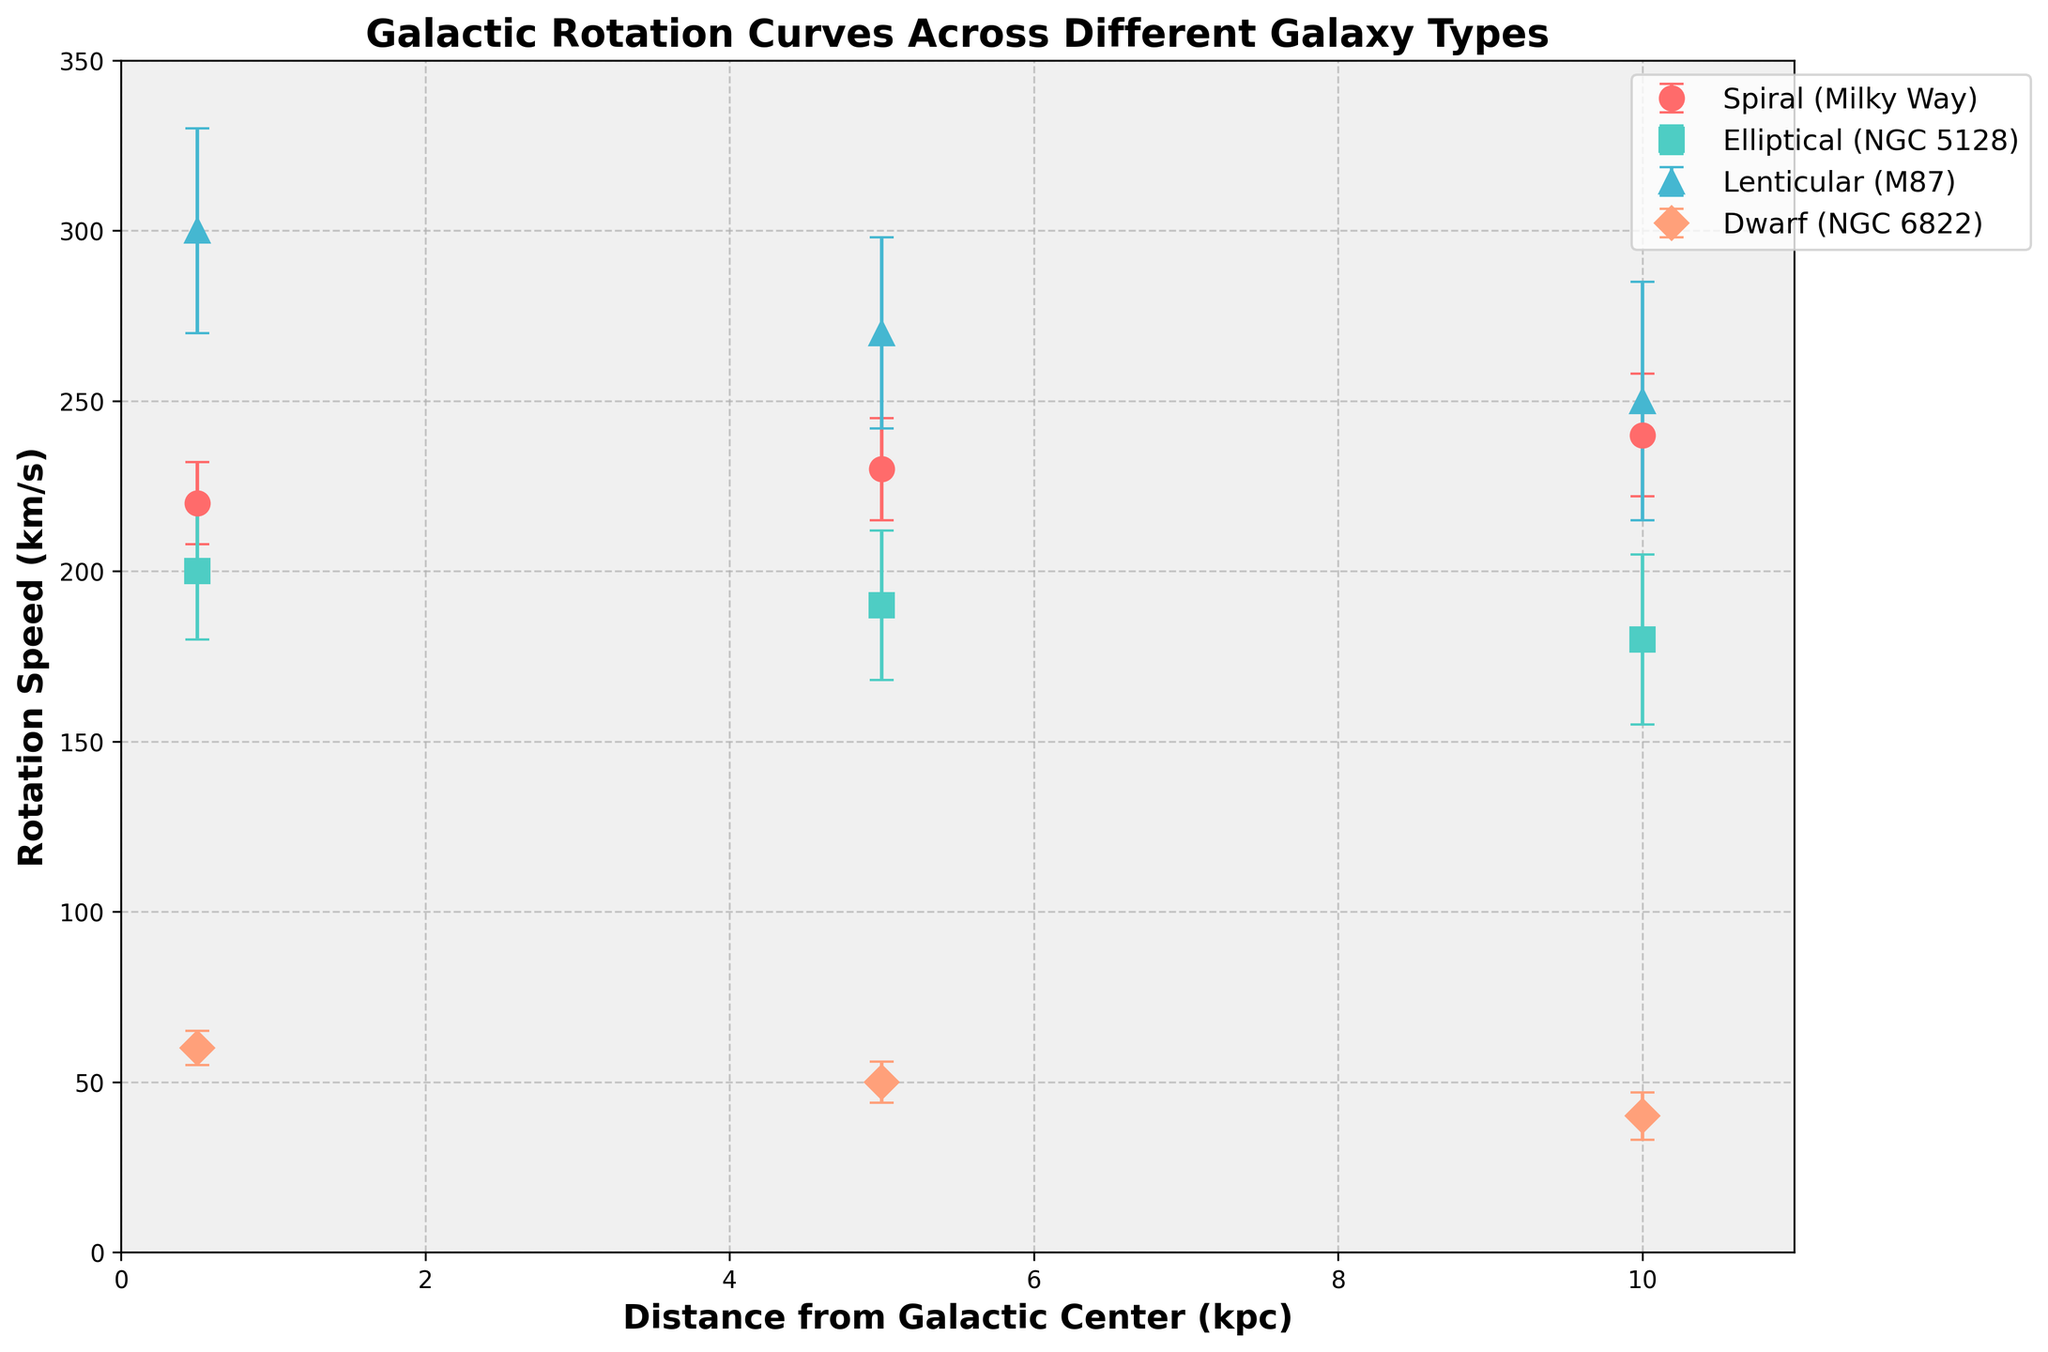What's the title of the plot? The title is usually found at the top of the plot. By looking at the figure, one can easily read the title provided there.
Answer: Galactic Rotation Curves Across Different Galaxy Types Which galaxy type has the highest rotation speed at 0.5 kpc? Check the data points at 0.5 kpc for each galaxy type and compare their rotation speeds. The lenticular galaxy (M87) has the highest point.
Answer: Lenticular What are the x-axis and y-axis labels? The x-axis label is found along the horizontal axis and the y-axis label is found along the vertical axis. By reading both labels, one can identify them.
Answer: Distance from Galactic Center (kpc) and Rotation Speed (km/s) How does the rotation speed of the Milky Way change from 0.5 kpc to 10 kpc? Compare the rotation speed values of the Milky Way at 0.5 kpc, 5.0 kpc, and 10 kpc. Observe the pattern of change.
Answer: It increases from 220 km/s to 240 km/s What is the error margin for the rotation speed of NGC 5128 at 5 kpc? Locate the data point for NGC 5128 (Elliptical) at 5 kpc and refer to the error bar length to find the error margin.
Answer: 22 km/s Which galaxy type shows the least change in rotation speed from 0.5 kpc to 10 kpc? Compare the rotation speeds at 0.5 kpc and 10 kpc for each galaxy type and determine which has the smallest difference.
Answer: Dwarf Between which two distances does M87 show the greatest drop in rotation speed? Calculate the differences in rotation speeds of M87 (Lenticular) between consecutive distances and identify the pair with the largest drop.
Answer: Between 0.5 kpc and 5 kpc Which galaxy type has the lowest rotation speed at 10 kpc, and what is that speed? Look at the data points at 10 kpc for each galaxy type and find the lowest value.
Answer: Dwarf, 40 km/s Between which two distances does the Milky Way have the largest increase in rotation speed? Calculate the differences in rotation speeds of the Milky Way between consecutive distances and identify the pair with the largest increase.
Answer: Between 5 kpc and 10 kpc 